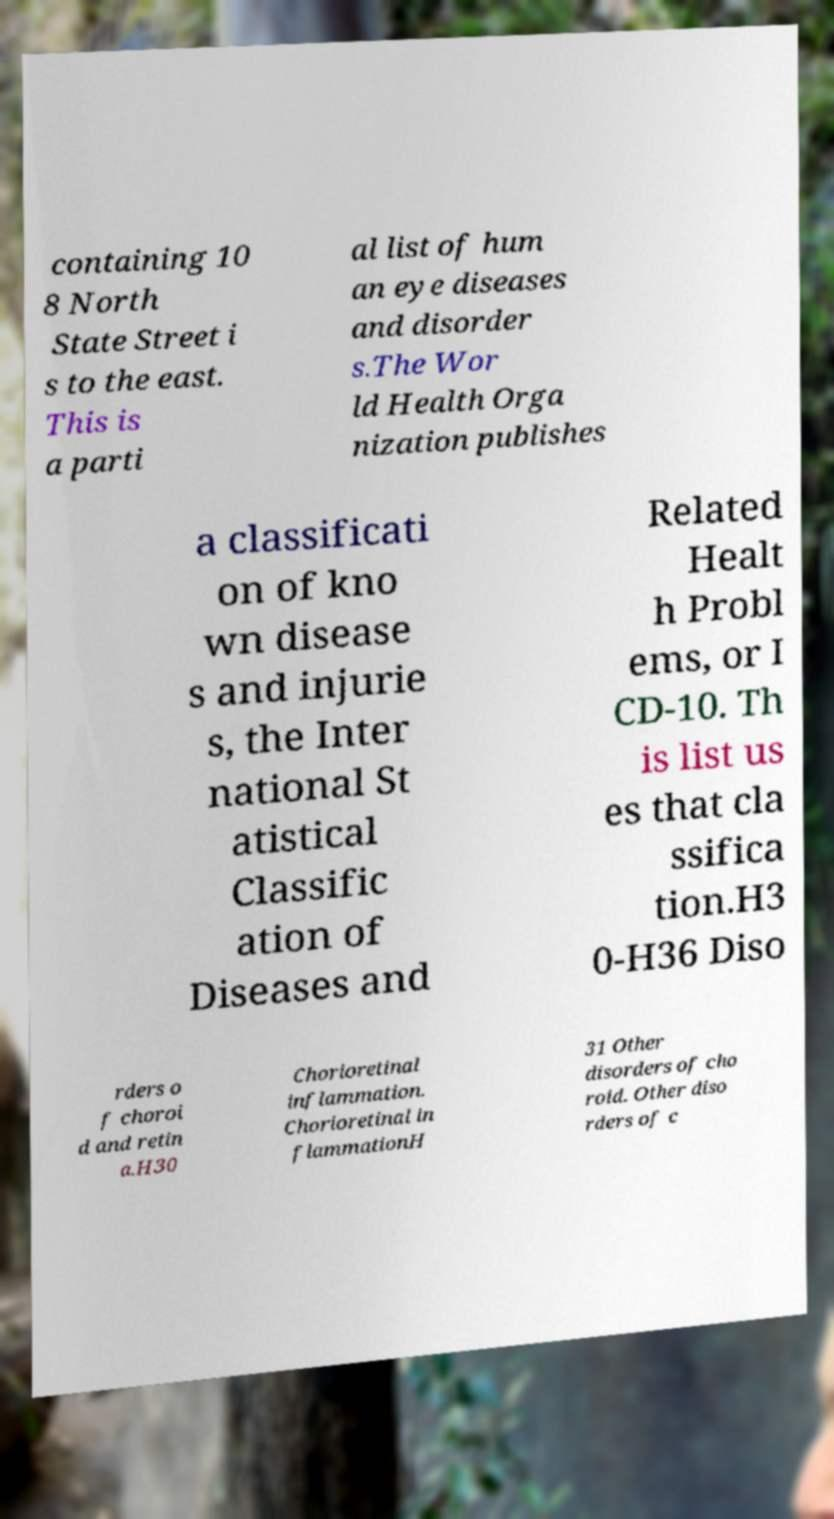For documentation purposes, I need the text within this image transcribed. Could you provide that? containing 10 8 North State Street i s to the east. This is a parti al list of hum an eye diseases and disorder s.The Wor ld Health Orga nization publishes a classificati on of kno wn disease s and injurie s, the Inter national St atistical Classific ation of Diseases and Related Healt h Probl ems, or I CD-10. Th is list us es that cla ssifica tion.H3 0-H36 Diso rders o f choroi d and retin a.H30 Chorioretinal inflammation. Chorioretinal in flammationH 31 Other disorders of cho roid. Other diso rders of c 